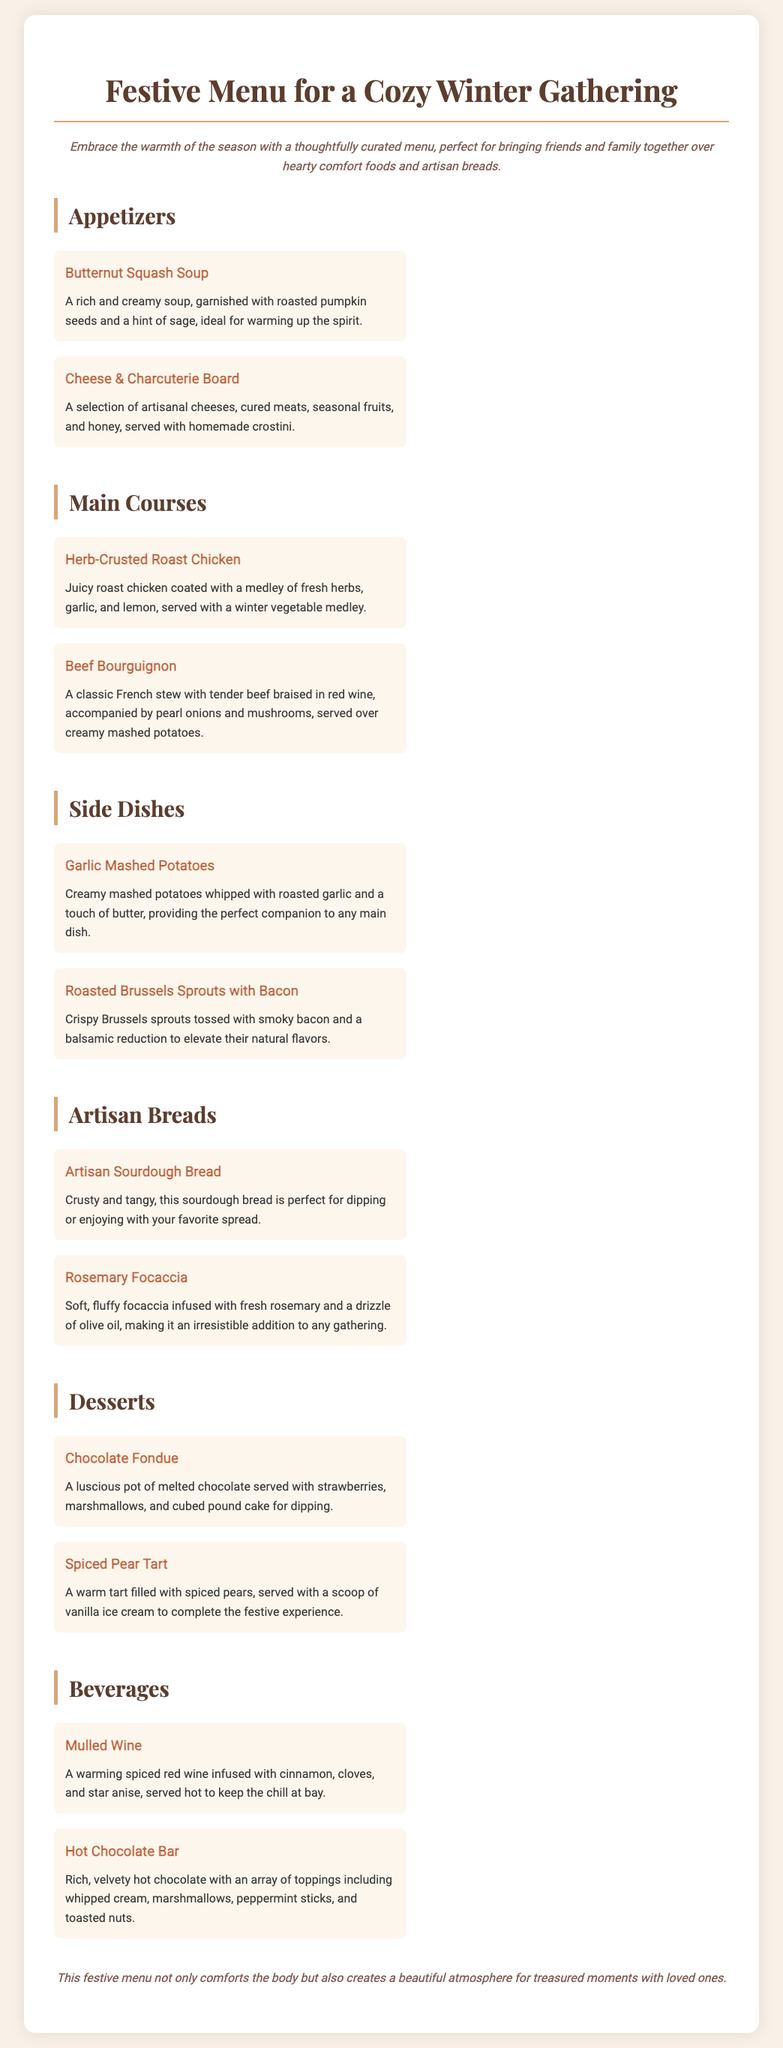What is the title of the menu? The title of the menu is featured prominently at the top of the document.
Answer: Festive Menu for a Cozy Winter Gathering What type of soup is featured as an appetizer? The specific type of soup is listed among the appetizers in the document.
Answer: Butternut Squash Soup How many main courses are listed in the menu? The document outlines the number of main courses provided.
Answer: 2 What is the name of one of the artisan breads? The menu mentions specific types of artisan breads served.
Answer: Artisan Sourdough Bread Which dessert includes melted chocolate? The dessert section specifically describes a dessert involving melted chocolate.
Answer: Chocolate Fondue What beverage is infused with spices? The beverages section highlights a drink that is spiced and served hot.
Answer: Mulled Wine What type of cheese is mentioned in the cheese board? The menu item includes a variety of cheeses in the description.
Answer: Artisanal cheeses What is the garnish for the Butternut Squash Soup? The specific garnish for the soup is detailed in its description.
Answer: Roasted pumpkin seeds and a hint of sage What main course is served with creamy mashed potatoes? The document identifies which main dish is accompanied by mashed potatoes.
Answer: Beef Bourguignon 